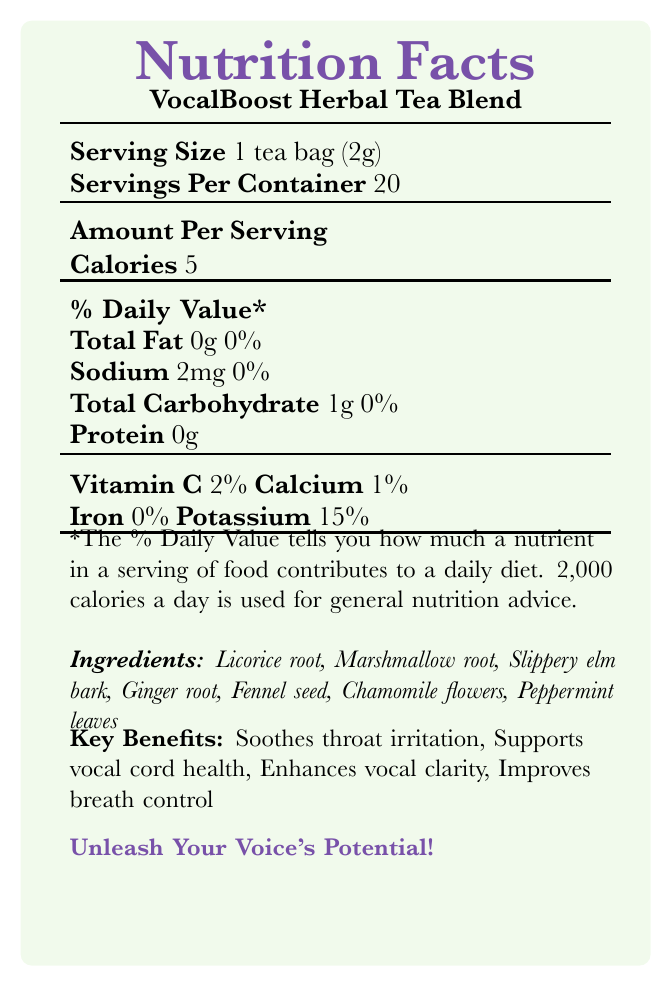what is the serving size? The document explicitly states the serving size as "1 tea bag (2g)".
Answer: 1 tea bag (2g) how many calories are in one serving? According to the document, the "Amount Per Serving" shows that there are 5 calories per serving.
Answer: 5 what ingredient is not recommended for pregnant or nursing women? The warnings section in the document advises that the product is "Not recommended for pregnant or nursing women". Licorice root is an ingredient known to have effects that could be concerning during pregnancy.
Answer: Licorice root how many servings are in a container? The document specifies that there are 20 servings per container.
Answer: 20 how much potassium is in one serving? The document shows that one serving contains 15% of the Daily Value for potassium.
Answer: 15% which of these is a key benefit of the tea? A. Weight Loss B. Soothes throat irritation C. Boosts immunity D. Increases metabolism The document lists "Soothes throat irritation" as one of the key benefits.
Answer: B how much protein is in one serving? A. 1g B. 2g C. 3g D. 0g The document lists the protein content per serving as 0g.
Answer: D is the tea caffeine-free? The additional info section of the document states that the tea is caffeine-free.
Answer: Yes how many grams of carbohydrates does a serving contain? The "Total Carbohydrate" listed in the document is 1g per serving.
Answer: 1g what are the ingredients of the tea? The document provides a list of ingredients under the "Ingredients" section.
Answer: Licorice root, Marshmallow root, Slippery elm bark, Ginger root, Fennel seed, Chamomile flowers, Peppermint leaves how should you prepare the tea? The document provides specific instructions for preparing and consuming the tea under the "suggested use" section.
Answer: Steep 1 tea bag in 8 oz of hot water for 5-7 minutes. Drink 2-3 cups daily, especially before performances. does the tea contain any iron? The document indicates "Iron 0%" in the nutritional information.
Answer: No what is the main target market for the herbal tea? A. General tea drinkers B. Choir members and vocalists C. Dieting individuals D. Athletes The document suggests that the tea is designed to improve vocal performance, making it more suitable for choir members and vocalists.
Answer: B summarize the main features of the document. This summary encapsulates the major points covered in the document, including nutritional facts, ingredients, benefits, and other notable features.
Answer: The document provides nutritional information for VocalBoost Herbal Tea Blend, detailing its calorie, fat, sodium, carbohydrate, protein, vitamin, and mineral content. It lists the ingredients and emphasizes key benefits for vocal health. The document also includes preparation instructions, warnings, testimonials, comparisons with other products, and additional information on its organic and sustainable nature. what is the price difference between VocalBoost and King's College Choir Secret Blend? The document states that the King's College Choir Secret Blend is priced at £24.99, while VocalBoost is priced at £19.99. The difference is £5.00.
Answer: £5.00 does the tea contain any caffeine or hormones? The document only mentions that the tea is caffeine-free; it does not provide any information on whether it contains hormones.
Answer: Cannot be determined 